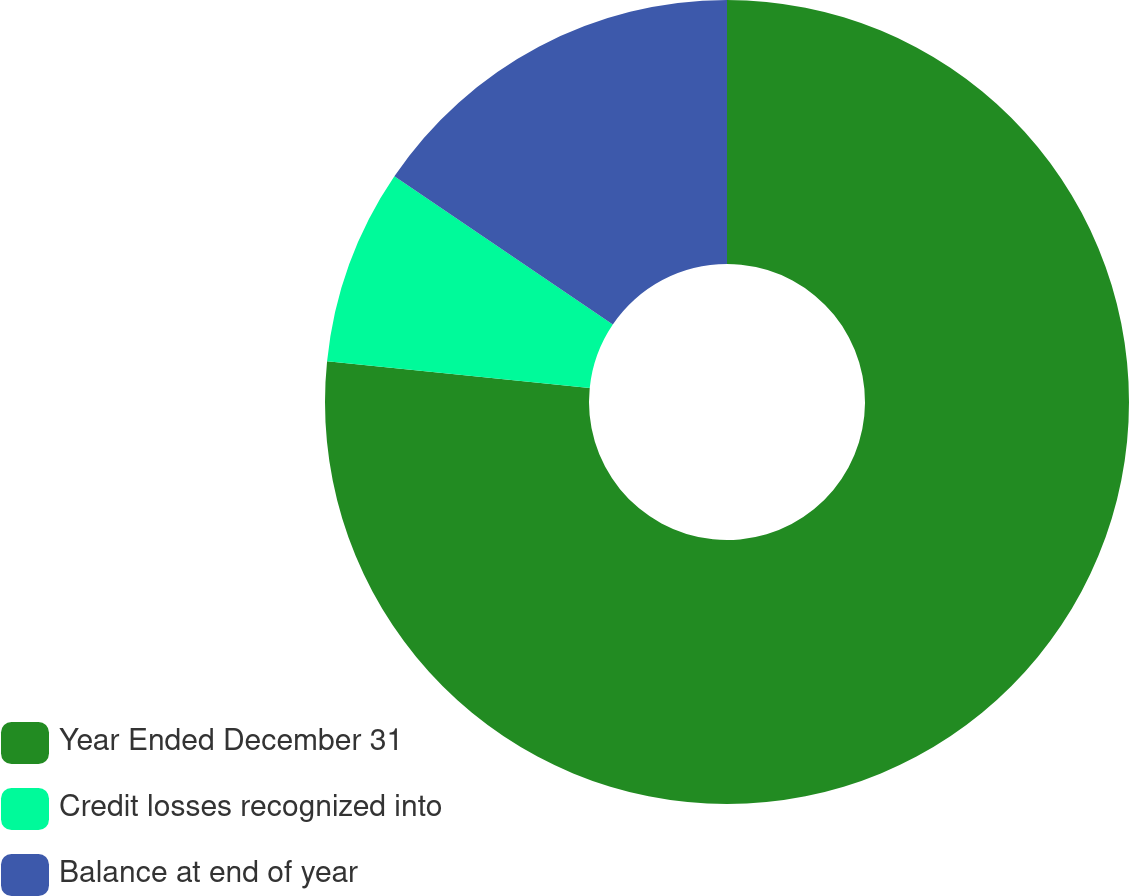Convert chart. <chart><loc_0><loc_0><loc_500><loc_500><pie_chart><fcel>Year Ended December 31<fcel>Credit losses recognized into<fcel>Balance at end of year<nl><fcel>76.62%<fcel>7.87%<fcel>15.51%<nl></chart> 